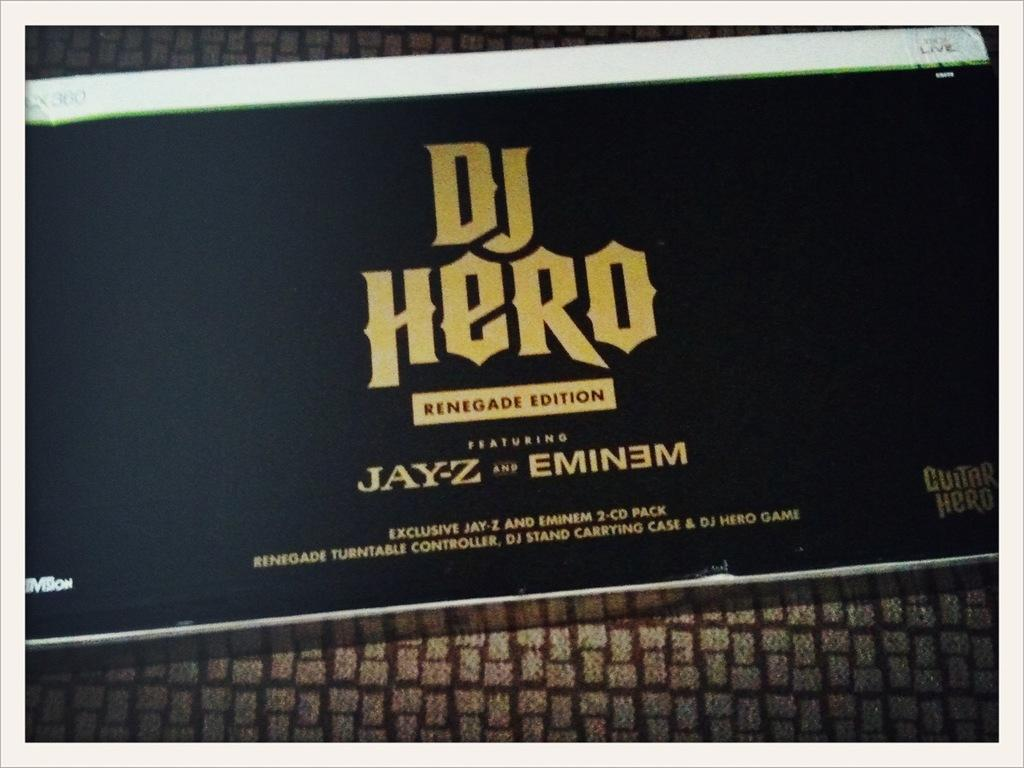Provide a one-sentence caption for the provided image. Guitar Hero Dj Hero Rednegade Edition featuring Jay-z qand Eminem. 